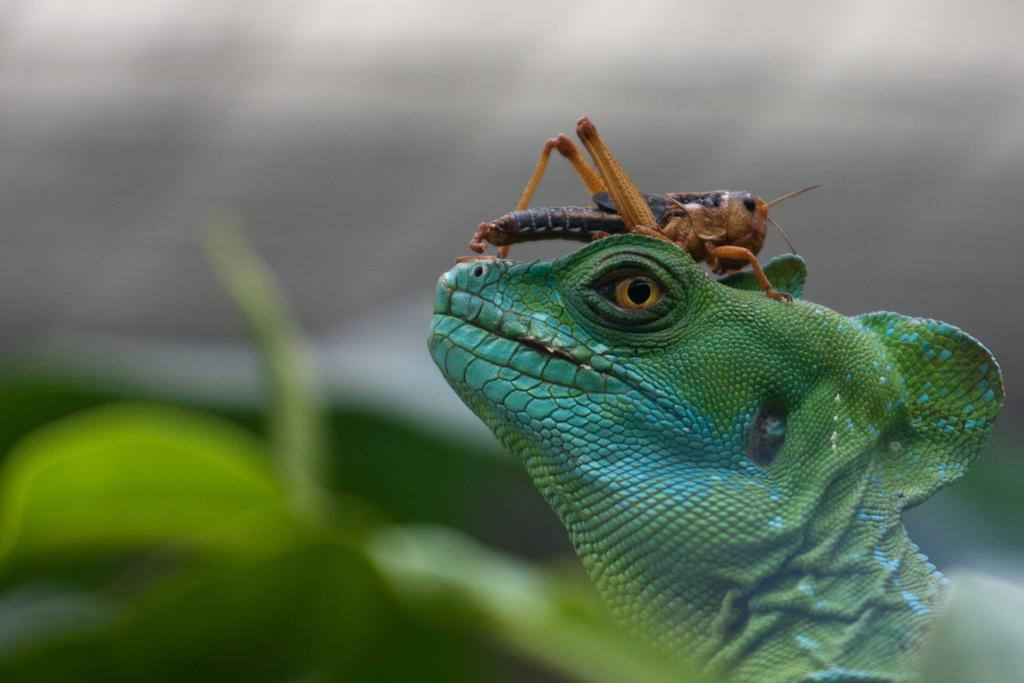What type of animal can be seen in the image? There is an insect and a chameleon in the image. What color is the chameleon? The chameleon is green in color. How does the background of the image appear? The background of the image appears blurry. Is there a sail visible in the image? No, there is no sail present in the image. Are the insect and chameleon engaged in a fight in the image? No, there is no indication of a fight between the insect and chameleon in the image. 